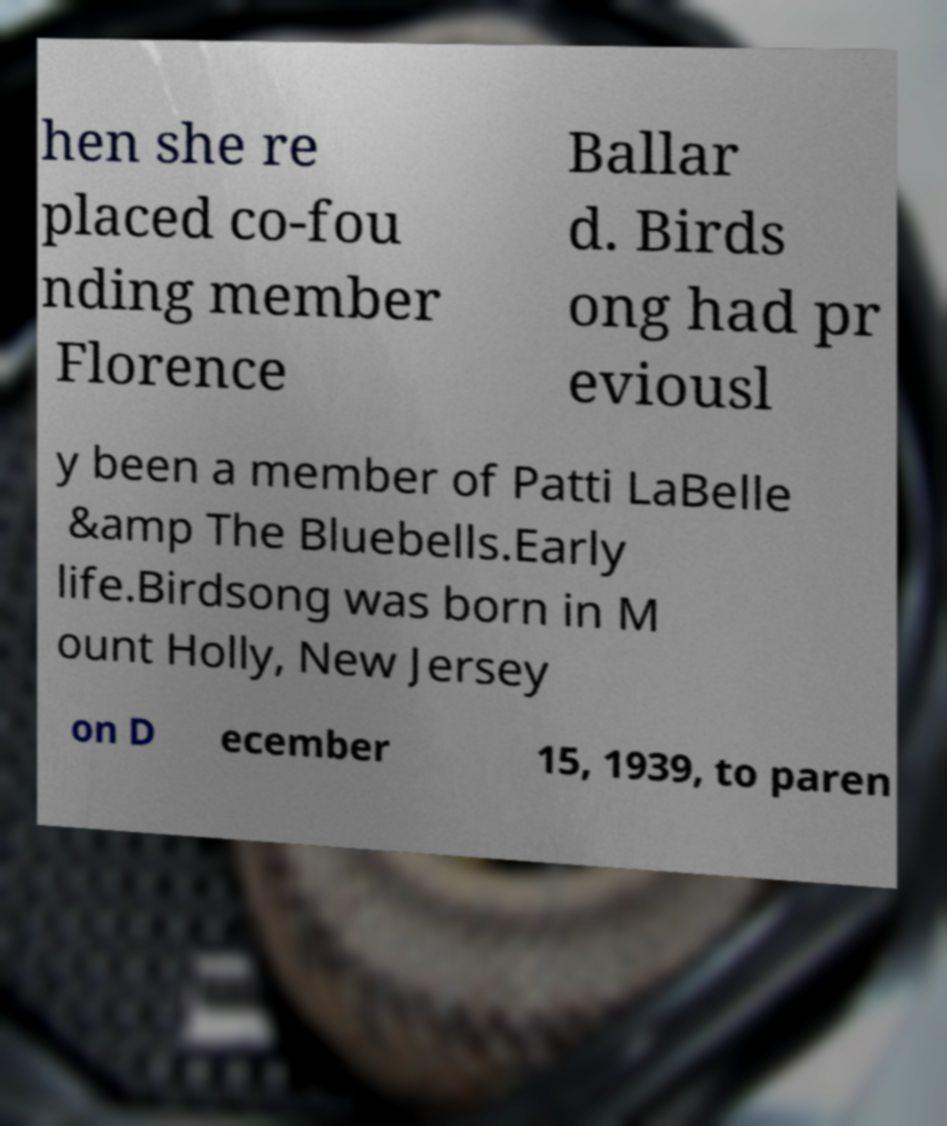Please read and relay the text visible in this image. What does it say? hen she re placed co-fou nding member Florence Ballar d. Birds ong had pr eviousl y been a member of Patti LaBelle &amp The Bluebells.Early life.Birdsong was born in M ount Holly, New Jersey on D ecember 15, 1939, to paren 